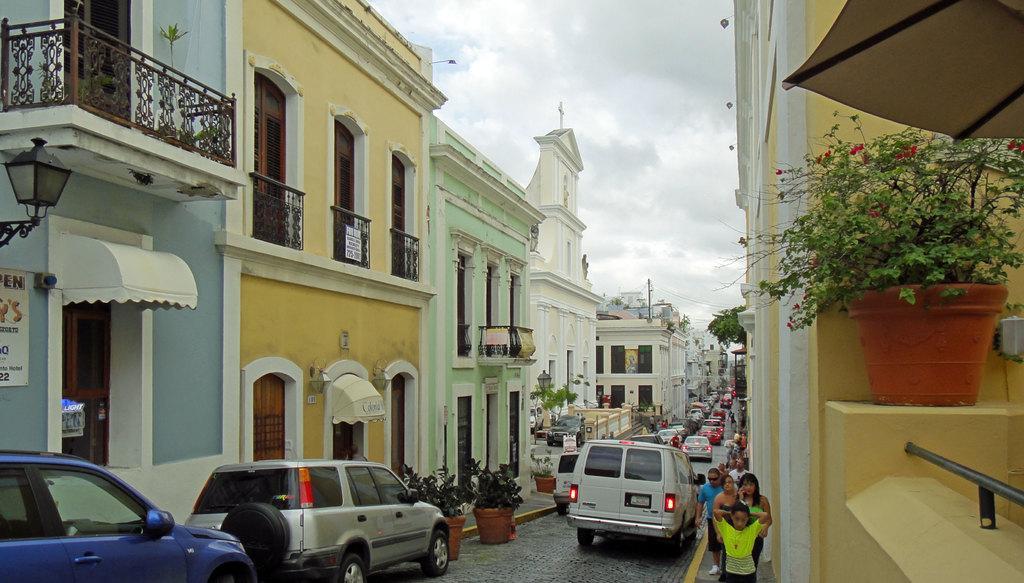Could you give a brief overview of what you see in this image? In this image in the front on the right side there is a plant in the pot and there is railing. In the center there are vehicles moving on the road, there are persons walking, there are plants and there are buildings and on the building there is a board with some text written on it. In the background there are buildings, trees, there are vehicles moving on the road, there are persons and the sky is cloudy. 